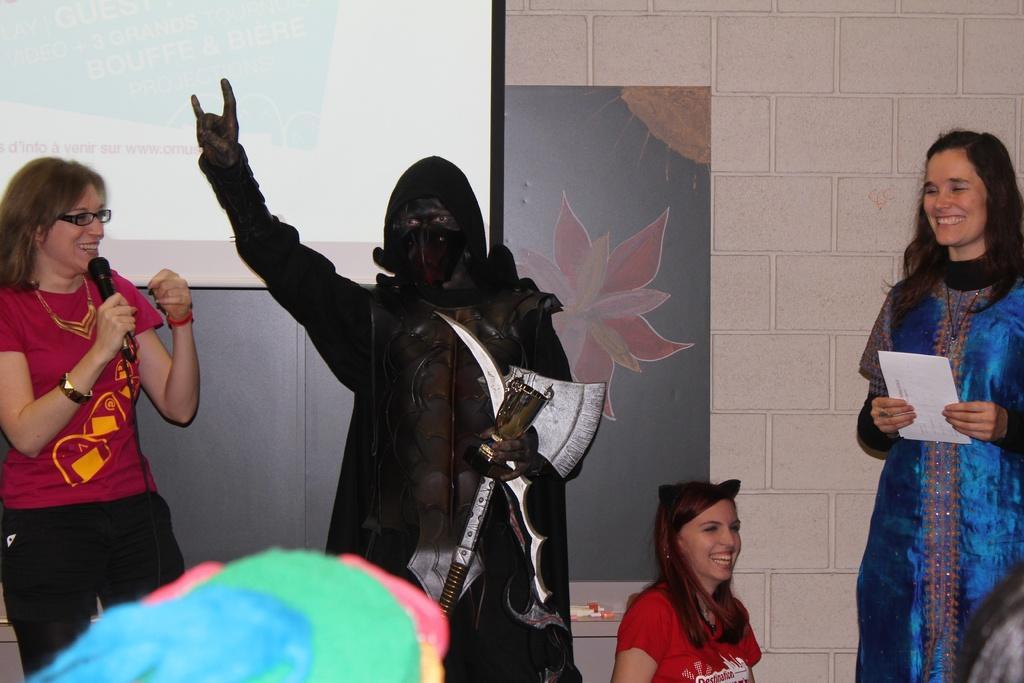Could you give a brief overview of what you see in this image? Here we can see four persons. She is talking on the mike and they are smiling. Here we can see a person in a fancy dress and he is holding weapons and a trophy with his hand. In the background we can see a wall, frame, and a screen. 